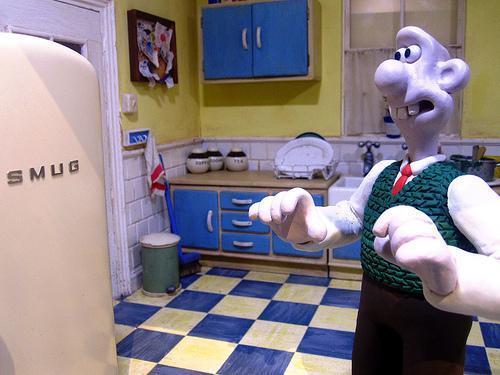How many teeth does Wallace have?
Give a very brief answer. 3. How many handles are on the cupboard?
Give a very brief answer. 2. 